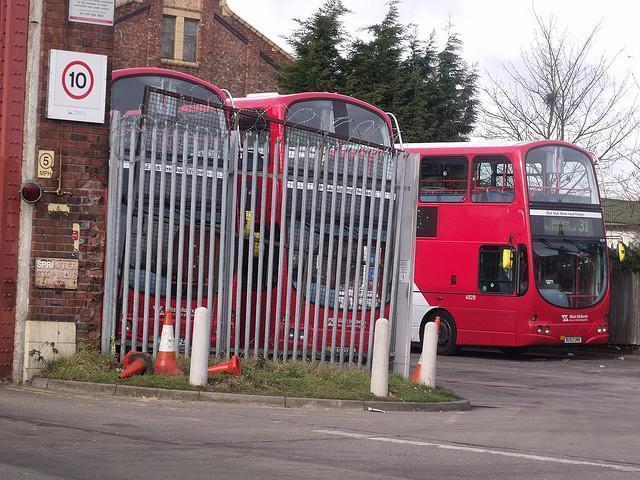Which side of the street do the busses seen here travel when driving forward?
Make your selection from the four choices given to correctly answer the question.
Options: None, right, center only, left. Left. 